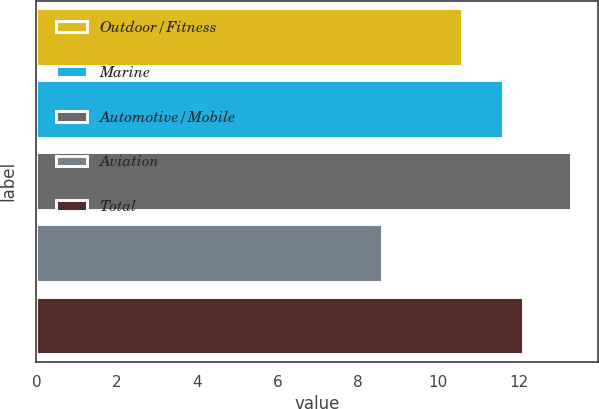Convert chart to OTSL. <chart><loc_0><loc_0><loc_500><loc_500><bar_chart><fcel>Outdoor/Fitness<fcel>Marine<fcel>Automotive/Mobile<fcel>Aviation<fcel>Total<nl><fcel>10.6<fcel>11.6<fcel>13.3<fcel>8.6<fcel>12.1<nl></chart> 